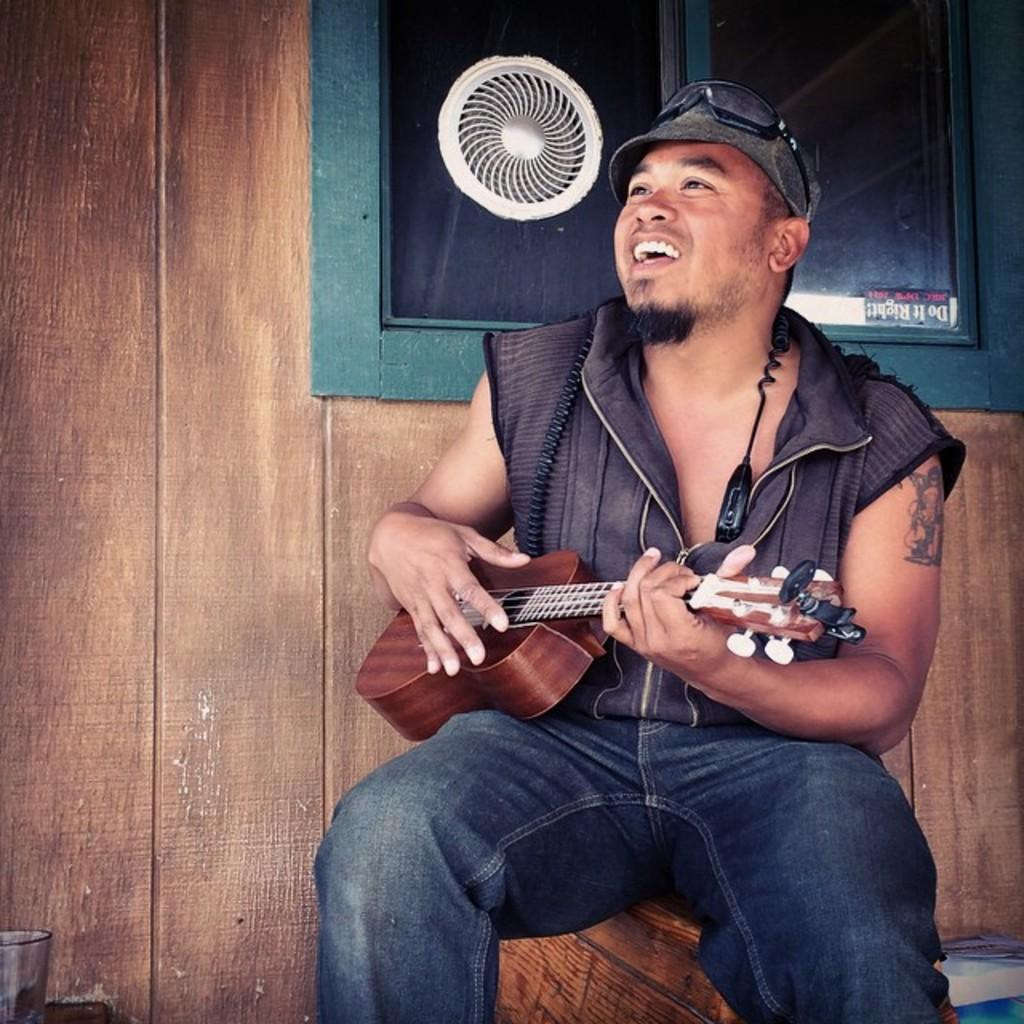What is the man in the image doing? The man is playing a guitar. What type of clothing is the man wearing? The man is wearing a jacket, a hat, and blue jeans. What can be seen in the background of the image? There is a wood wall and a window in the background of the image. What type of channel can be seen in the image? There is no channel present in the image. Can you describe the sidewalk in the image? There is no sidewalk present in the image. 